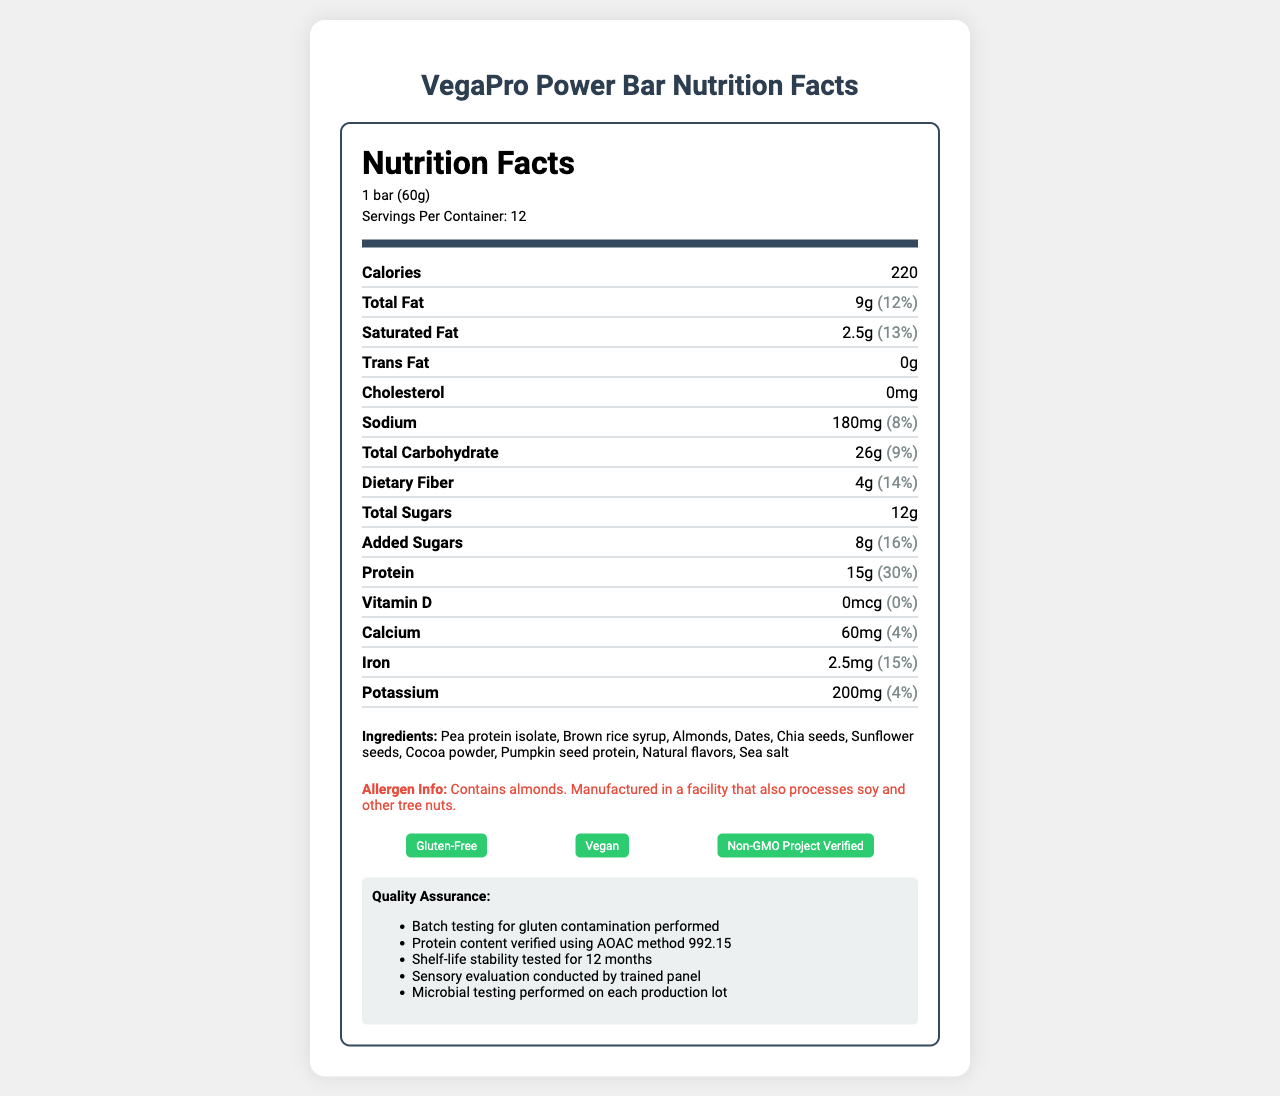what is the serving size of the VegaPro Power Bar? The serving size is mentioned at the beginning of the nutrition facts section.
Answer: 1 bar (60g) how many servings are there in one container? The number of servings is listed as "Servings Per Container: 12" in the nutrition facts section.
Answer: 12 what percentage of the daily value for protein does one bar provide? The daily value percentage for protein is provided adjacent to the protein amount in the nutrition facts section.
Answer: 30% which ingredient is listed first in the ingredients list? The ingredients are listed in descending order by weight, and pea protein isolate is listed first.
Answer: Pea protein isolate how much dietary fiber does one bar contain? The dietary fiber content is listed under the nutrient section, showing "4g."
Answer: 4g how many calories are in one bar? A. 180 B. 200 C. 220 The document shows that each bar contains 220 calories in the nutrition facts section.
Answer: C what is the total fat content in one bar? A. 7g B. 8g C. 9g D. 10g The total fat content is listed as "9g" in the nutrition facts section.
Answer: C is the VegaPro Power Bar certified gluten-free? The certifications include "Gluten-Free," indicating the bar is certified gluten-free.
Answer: Yes is there any trans fat in the VegaPro Power Bar? The document shows that the amount of trans fat is "0g."
Answer: No is the sodium content less than 200mg per bar? The sodium content is 180mg per bar, which is less than 200mg.
Answer: Yes how is the protein content verified? The quality assurance notes indicate that the protein content is verified using AOAC method 992.15.
Answer: Using AOAC method 992.15 is the product manufactured in a facility that processes soy? The allergen info mentions it is manufactured in a facility that processes soy.
Answer: Yes summarize the nutrition facts label of the VegaPro Power Bar The summary encapsulates the nutritional content, allergen information, certifications, and the overall plant-based and gluten-free status of the bar as highlighted in the nutrition facts label.
Answer: The VegaPro Power Bar nutrition facts label highlights that the bar is a gluten-free, vegan, and non-GMO product with each serving containing 220 calories. Key nutrients include 9g of total fat, 15g of protein, 4g dietary fiber, and 12g of total sugars. The label also includes allergen information, certifications, quality assurance notes, and a detailed list of plant-based ingredients. what is the source of the brown rice syrup used in the VegaPro Power Bar? The document does not provide information about the source or origin of brown rice syrup used in the bar.
Answer: Cannot be determined 